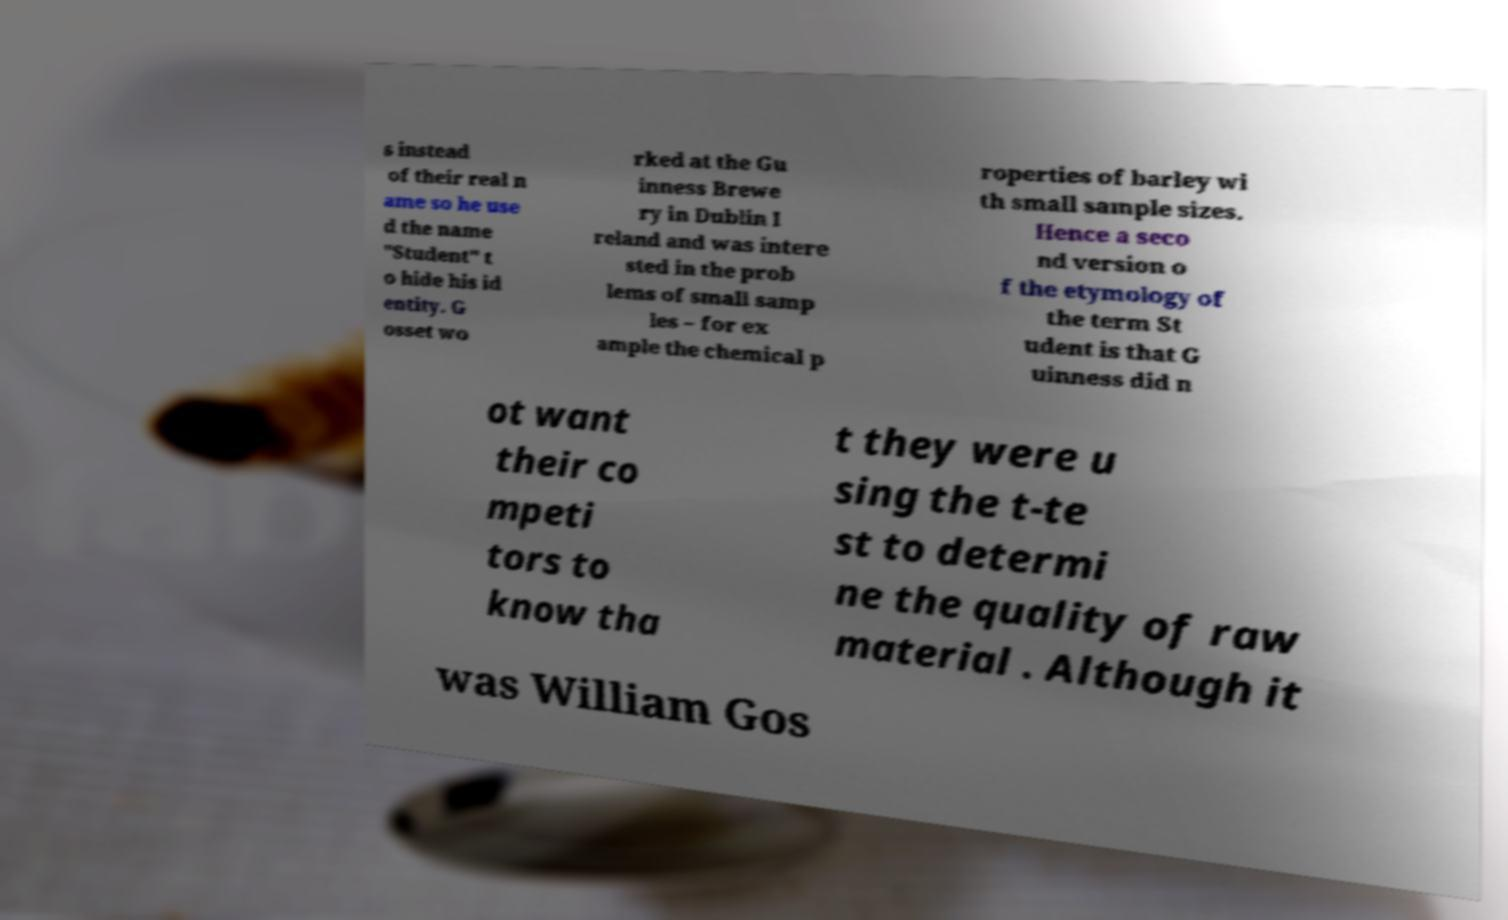I need the written content from this picture converted into text. Can you do that? s instead of their real n ame so he use d the name "Student" t o hide his id entity. G osset wo rked at the Gu inness Brewe ry in Dublin I reland and was intere sted in the prob lems of small samp les – for ex ample the chemical p roperties of barley wi th small sample sizes. Hence a seco nd version o f the etymology of the term St udent is that G uinness did n ot want their co mpeti tors to know tha t they were u sing the t-te st to determi ne the quality of raw material . Although it was William Gos 